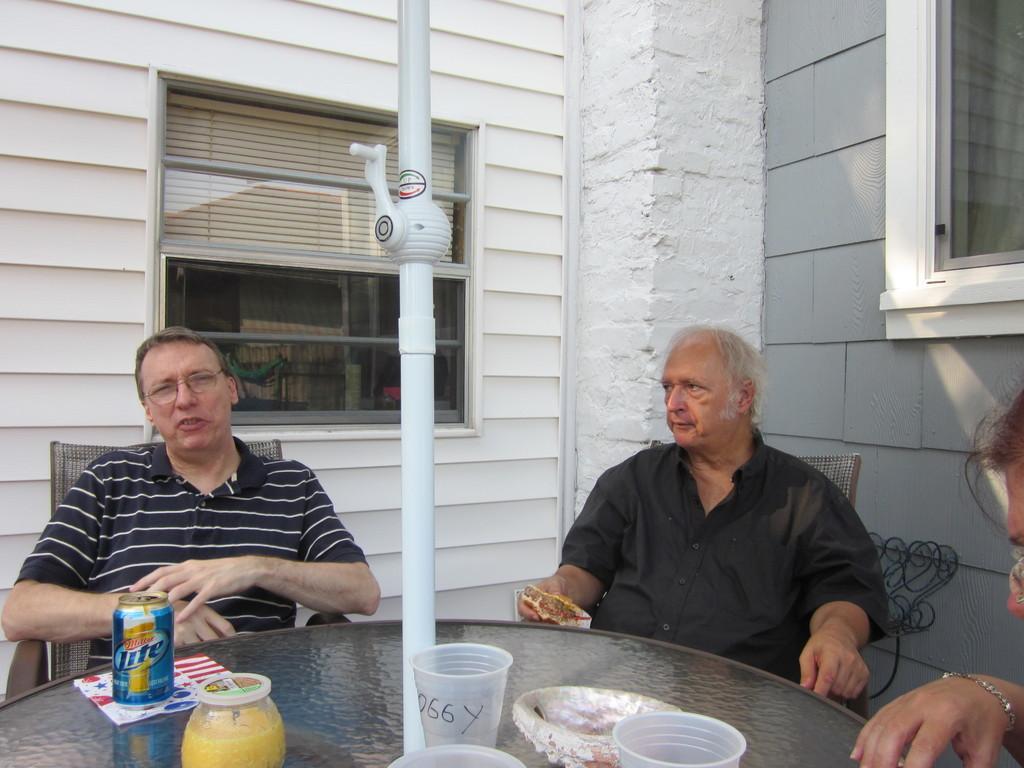Can you describe this image briefly? In this image there were three people sitting on a chairs and having their food. At the bottom of the image there is a table on which there are a tin with coke in it, a jar and a glass. At the background there is a wall with window and window blind. 